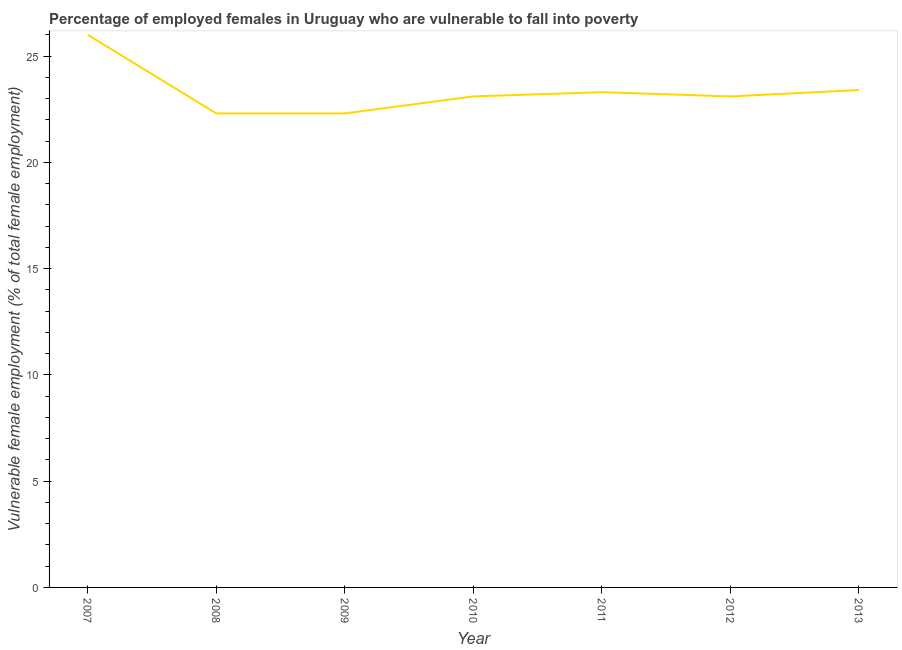What is the percentage of employed females who are vulnerable to fall into poverty in 2013?
Offer a terse response. 23.4. Across all years, what is the minimum percentage of employed females who are vulnerable to fall into poverty?
Provide a succinct answer. 22.3. In which year was the percentage of employed females who are vulnerable to fall into poverty minimum?
Your answer should be very brief. 2008. What is the sum of the percentage of employed females who are vulnerable to fall into poverty?
Your answer should be compact. 163.5. What is the difference between the percentage of employed females who are vulnerable to fall into poverty in 2007 and 2011?
Offer a terse response. 2.7. What is the average percentage of employed females who are vulnerable to fall into poverty per year?
Your answer should be compact. 23.36. What is the median percentage of employed females who are vulnerable to fall into poverty?
Make the answer very short. 23.1. In how many years, is the percentage of employed females who are vulnerable to fall into poverty greater than 15 %?
Your answer should be very brief. 7. What is the ratio of the percentage of employed females who are vulnerable to fall into poverty in 2008 to that in 2011?
Your answer should be very brief. 0.96. Is the difference between the percentage of employed females who are vulnerable to fall into poverty in 2008 and 2011 greater than the difference between any two years?
Your response must be concise. No. What is the difference between the highest and the second highest percentage of employed females who are vulnerable to fall into poverty?
Keep it short and to the point. 2.6. Is the sum of the percentage of employed females who are vulnerable to fall into poverty in 2007 and 2011 greater than the maximum percentage of employed females who are vulnerable to fall into poverty across all years?
Give a very brief answer. Yes. What is the difference between the highest and the lowest percentage of employed females who are vulnerable to fall into poverty?
Offer a terse response. 3.7. Does the percentage of employed females who are vulnerable to fall into poverty monotonically increase over the years?
Give a very brief answer. No. How many years are there in the graph?
Ensure brevity in your answer.  7. Are the values on the major ticks of Y-axis written in scientific E-notation?
Provide a short and direct response. No. Does the graph contain any zero values?
Provide a short and direct response. No. Does the graph contain grids?
Provide a succinct answer. No. What is the title of the graph?
Your answer should be very brief. Percentage of employed females in Uruguay who are vulnerable to fall into poverty. What is the label or title of the X-axis?
Offer a terse response. Year. What is the label or title of the Y-axis?
Provide a short and direct response. Vulnerable female employment (% of total female employment). What is the Vulnerable female employment (% of total female employment) in 2007?
Make the answer very short. 26. What is the Vulnerable female employment (% of total female employment) in 2008?
Give a very brief answer. 22.3. What is the Vulnerable female employment (% of total female employment) of 2009?
Your response must be concise. 22.3. What is the Vulnerable female employment (% of total female employment) of 2010?
Your response must be concise. 23.1. What is the Vulnerable female employment (% of total female employment) in 2011?
Offer a very short reply. 23.3. What is the Vulnerable female employment (% of total female employment) of 2012?
Offer a very short reply. 23.1. What is the Vulnerable female employment (% of total female employment) in 2013?
Give a very brief answer. 23.4. What is the difference between the Vulnerable female employment (% of total female employment) in 2007 and 2010?
Make the answer very short. 2.9. What is the difference between the Vulnerable female employment (% of total female employment) in 2007 and 2012?
Give a very brief answer. 2.9. What is the difference between the Vulnerable female employment (% of total female employment) in 2008 and 2009?
Your answer should be very brief. 0. What is the difference between the Vulnerable female employment (% of total female employment) in 2008 and 2010?
Make the answer very short. -0.8. What is the difference between the Vulnerable female employment (% of total female employment) in 2008 and 2011?
Your answer should be compact. -1. What is the difference between the Vulnerable female employment (% of total female employment) in 2008 and 2012?
Give a very brief answer. -0.8. What is the difference between the Vulnerable female employment (% of total female employment) in 2008 and 2013?
Your response must be concise. -1.1. What is the difference between the Vulnerable female employment (% of total female employment) in 2009 and 2011?
Your answer should be compact. -1. What is the difference between the Vulnerable female employment (% of total female employment) in 2009 and 2012?
Your response must be concise. -0.8. What is the difference between the Vulnerable female employment (% of total female employment) in 2010 and 2011?
Provide a short and direct response. -0.2. What is the difference between the Vulnerable female employment (% of total female employment) in 2010 and 2013?
Keep it short and to the point. -0.3. What is the ratio of the Vulnerable female employment (% of total female employment) in 2007 to that in 2008?
Provide a succinct answer. 1.17. What is the ratio of the Vulnerable female employment (% of total female employment) in 2007 to that in 2009?
Your answer should be compact. 1.17. What is the ratio of the Vulnerable female employment (% of total female employment) in 2007 to that in 2010?
Your answer should be compact. 1.13. What is the ratio of the Vulnerable female employment (% of total female employment) in 2007 to that in 2011?
Offer a very short reply. 1.12. What is the ratio of the Vulnerable female employment (% of total female employment) in 2007 to that in 2012?
Your answer should be compact. 1.13. What is the ratio of the Vulnerable female employment (% of total female employment) in 2007 to that in 2013?
Provide a succinct answer. 1.11. What is the ratio of the Vulnerable female employment (% of total female employment) in 2008 to that in 2010?
Offer a very short reply. 0.96. What is the ratio of the Vulnerable female employment (% of total female employment) in 2008 to that in 2011?
Offer a terse response. 0.96. What is the ratio of the Vulnerable female employment (% of total female employment) in 2008 to that in 2013?
Your answer should be compact. 0.95. What is the ratio of the Vulnerable female employment (% of total female employment) in 2009 to that in 2011?
Provide a short and direct response. 0.96. What is the ratio of the Vulnerable female employment (% of total female employment) in 2009 to that in 2012?
Your answer should be compact. 0.96. What is the ratio of the Vulnerable female employment (% of total female employment) in 2009 to that in 2013?
Make the answer very short. 0.95. What is the ratio of the Vulnerable female employment (% of total female employment) in 2010 to that in 2011?
Give a very brief answer. 0.99. What is the ratio of the Vulnerable female employment (% of total female employment) in 2010 to that in 2012?
Your answer should be compact. 1. What is the ratio of the Vulnerable female employment (% of total female employment) in 2011 to that in 2013?
Your answer should be compact. 1. 